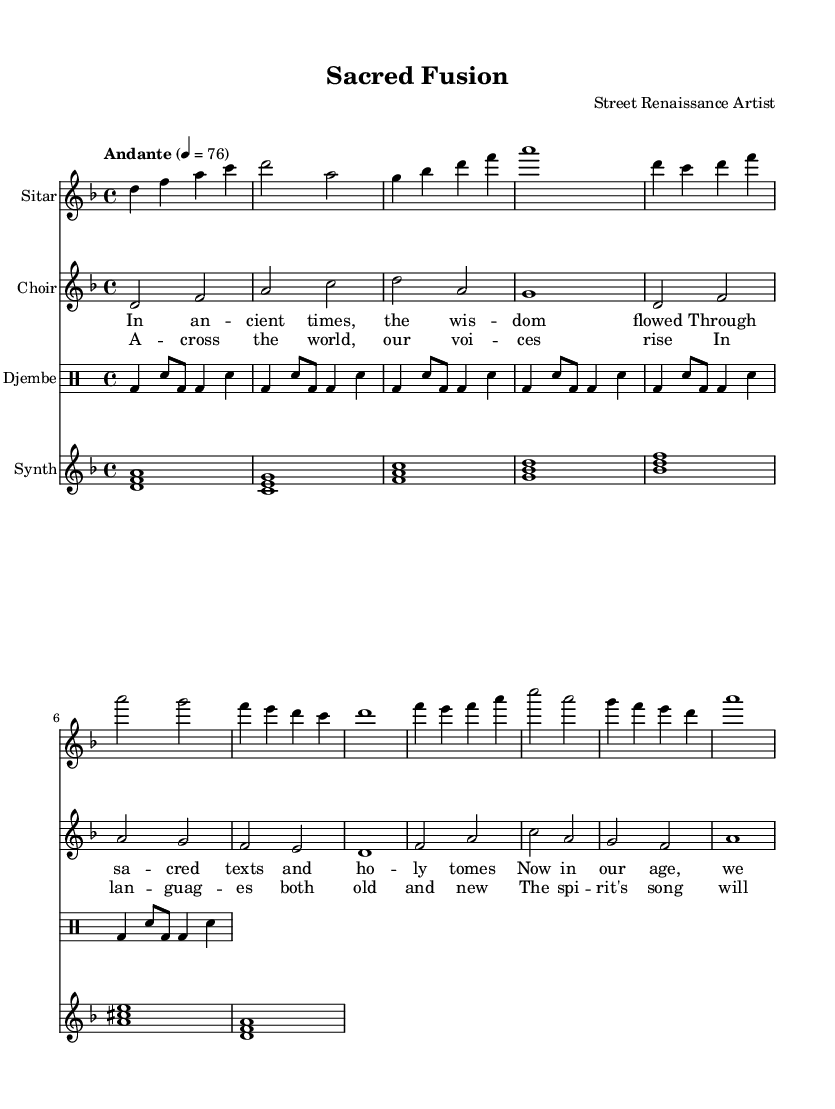What is the key signature of this music? The key signature indicates the tonal center of the piece. In this score, it is marked as 'd minor,' which often includes a B-flat.
Answer: d minor What is the time signature of the piece? The time signature is shown at the beginning of the score, indicating how the beats are organized in each measure. Here, it is set to 4/4, which means there are 4 beats per measure, with the quarter note receiving one beat.
Answer: 4/4 What is the tempo marking for the piece? The tempo marking is provided in the score, stating how fast the music should be played. In this case, it is marked as "Andante," which typically suggests a moderate pace.
Answer: Andante How many measures are there in the sitar part? To determine the number of measures, we can count the individual segments marked by vertical lines. Each segment represents one measure. There are 8 measures in the sitar part.
Answer: 8 Which instruments are included in this piece? The score lists the instruments at the beginning of each staff. The instruments present are Sitar, Choir, Djembe, and Synth. We can see this through the instrument names in each section of the score.
Answer: Sitar, Choir, Djembe, Synth What is the main theme of the lyrics used in the chorus? The chorus lyrics refer to themes of unity and connection, indicating how voices blend across different languages and cultures. Analyzing the words provides insight into the overall message of spiritual harmony.
Answer: Unity and connection 